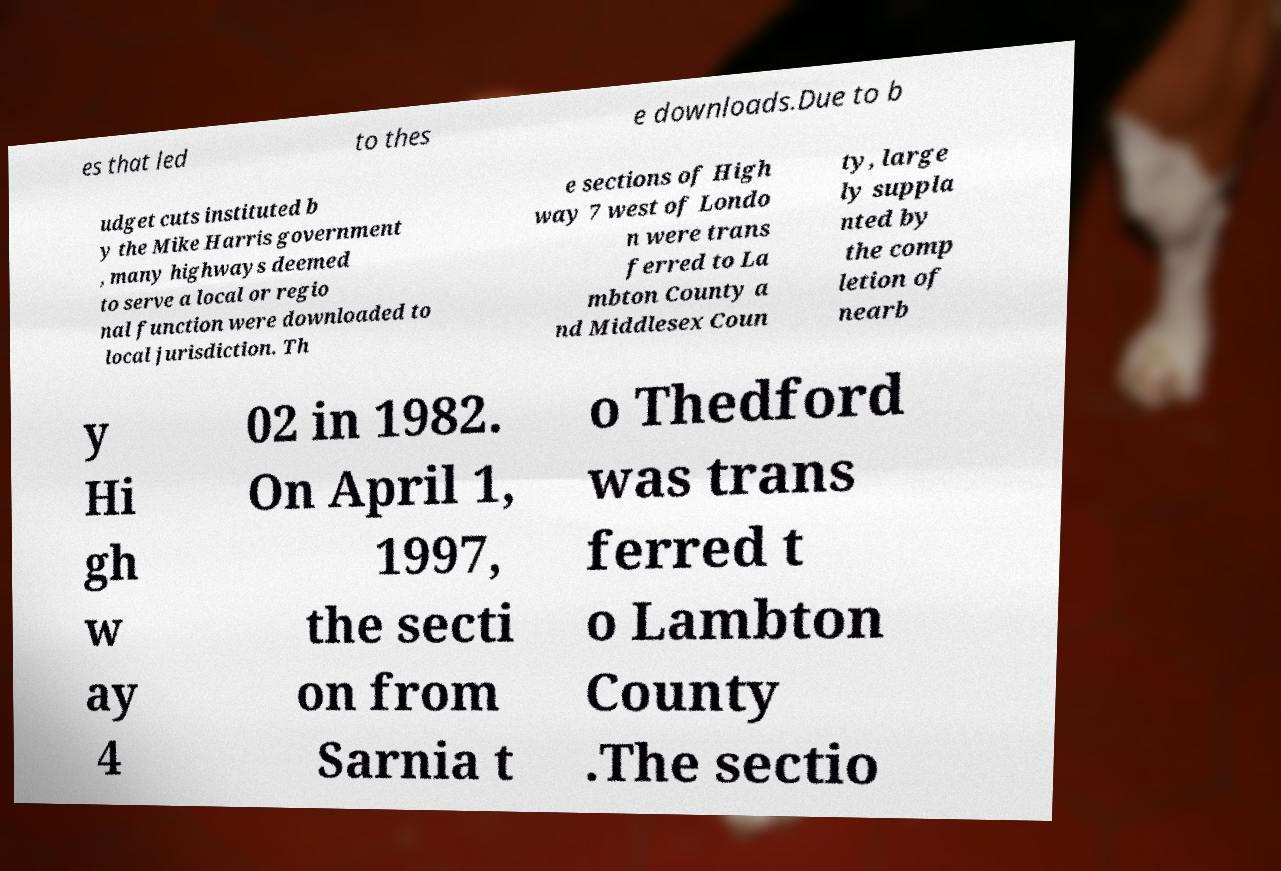Could you assist in decoding the text presented in this image and type it out clearly? es that led to thes e downloads.Due to b udget cuts instituted b y the Mike Harris government , many highways deemed to serve a local or regio nal function were downloaded to local jurisdiction. Th e sections of High way 7 west of Londo n were trans ferred to La mbton County a nd Middlesex Coun ty, large ly suppla nted by the comp letion of nearb y Hi gh w ay 4 02 in 1982. On April 1, 1997, the secti on from Sarnia t o Thedford was trans ferred t o Lambton County .The sectio 